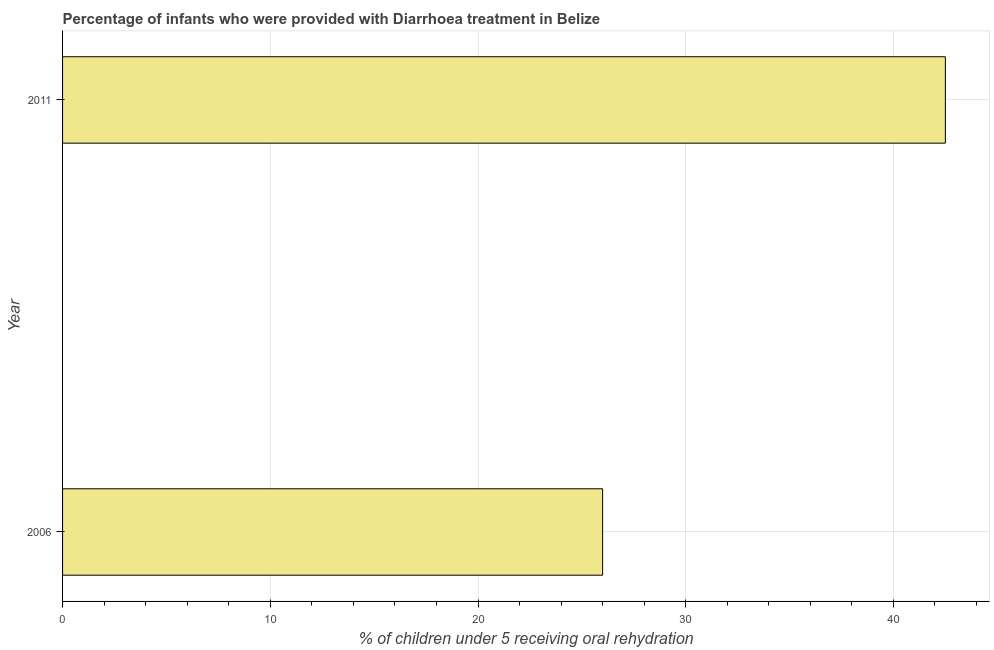Does the graph contain any zero values?
Your response must be concise. No. Does the graph contain grids?
Make the answer very short. Yes. What is the title of the graph?
Keep it short and to the point. Percentage of infants who were provided with Diarrhoea treatment in Belize. What is the label or title of the X-axis?
Offer a very short reply. % of children under 5 receiving oral rehydration. What is the percentage of children who were provided with treatment diarrhoea in 2011?
Your response must be concise. 42.5. Across all years, what is the maximum percentage of children who were provided with treatment diarrhoea?
Offer a very short reply. 42.5. Across all years, what is the minimum percentage of children who were provided with treatment diarrhoea?
Offer a very short reply. 26. What is the sum of the percentage of children who were provided with treatment diarrhoea?
Offer a terse response. 68.5. What is the difference between the percentage of children who were provided with treatment diarrhoea in 2006 and 2011?
Your answer should be very brief. -16.5. What is the average percentage of children who were provided with treatment diarrhoea per year?
Your answer should be very brief. 34.25. What is the median percentage of children who were provided with treatment diarrhoea?
Ensure brevity in your answer.  34.25. Do a majority of the years between 2011 and 2006 (inclusive) have percentage of children who were provided with treatment diarrhoea greater than 40 %?
Offer a terse response. No. What is the ratio of the percentage of children who were provided with treatment diarrhoea in 2006 to that in 2011?
Make the answer very short. 0.61. How many bars are there?
Your answer should be very brief. 2. What is the difference between two consecutive major ticks on the X-axis?
Offer a terse response. 10. Are the values on the major ticks of X-axis written in scientific E-notation?
Make the answer very short. No. What is the % of children under 5 receiving oral rehydration of 2011?
Offer a terse response. 42.5. What is the difference between the % of children under 5 receiving oral rehydration in 2006 and 2011?
Make the answer very short. -16.5. What is the ratio of the % of children under 5 receiving oral rehydration in 2006 to that in 2011?
Provide a succinct answer. 0.61. 